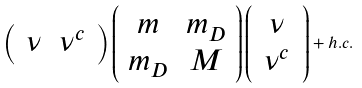Convert formula to latex. <formula><loc_0><loc_0><loc_500><loc_500>\left ( \, \begin{array} { c c } \nu & \nu ^ { c } \end{array} \, \right ) \left ( \begin{array} { c c } m & m _ { D } \\ m _ { D } & M \end{array} \right ) \left ( \, \begin{array} { c } \nu \\ \nu ^ { c } \end{array} \, \right ) + h . c .</formula> 